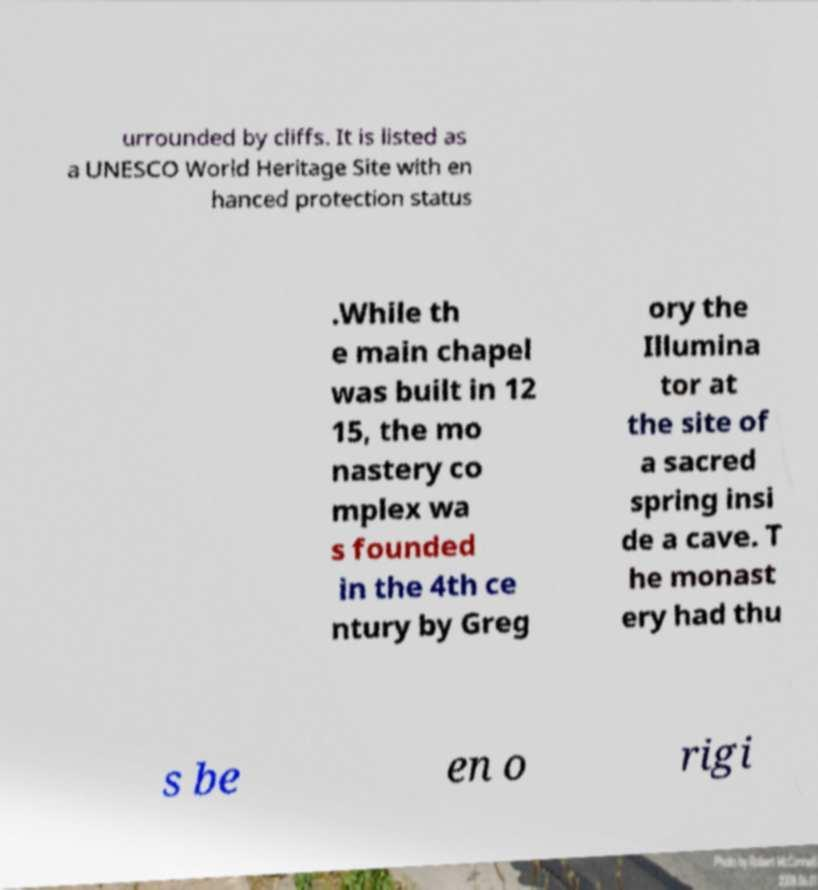Could you assist in decoding the text presented in this image and type it out clearly? urrounded by cliffs. It is listed as a UNESCO World Heritage Site with en hanced protection status .While th e main chapel was built in 12 15, the mo nastery co mplex wa s founded in the 4th ce ntury by Greg ory the Illumina tor at the site of a sacred spring insi de a cave. T he monast ery had thu s be en o rigi 